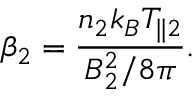Convert formula to latex. <formula><loc_0><loc_0><loc_500><loc_500>\beta _ { 2 } = \frac { n _ { 2 } k _ { B } T _ { \| 2 } } { B _ { 2 } ^ { 2 } / 8 \pi } .</formula> 